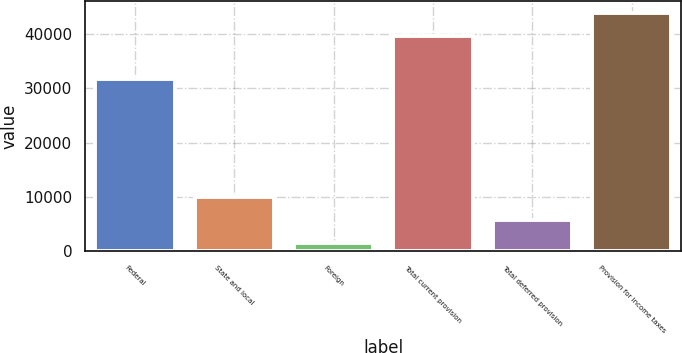Convert chart. <chart><loc_0><loc_0><loc_500><loc_500><bar_chart><fcel>Federal<fcel>State and local<fcel>Foreign<fcel>Total current provision<fcel>Total deferred provision<fcel>Provision for income taxes<nl><fcel>31700<fcel>9910.8<fcel>1456<fcel>39661<fcel>5683.4<fcel>43888.4<nl></chart> 